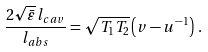<formula> <loc_0><loc_0><loc_500><loc_500>\frac { 2 \sqrt { \bar { \varepsilon } } \, l _ { c a v } } { l _ { a b s } } = \sqrt { T _ { 1 } T _ { 2 } } \left ( v - u ^ { - 1 } \right ) \, .</formula> 